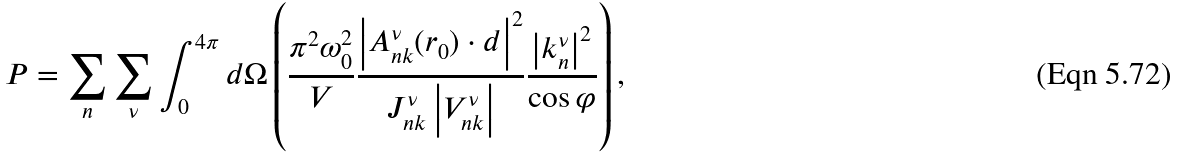<formula> <loc_0><loc_0><loc_500><loc_500>P = \sum _ { n } \sum _ { \nu } \int _ { 0 } ^ { 4 \pi } d \Omega \left ( \frac { \pi ^ { 2 } \omega _ { 0 } ^ { 2 } } { V } \frac { \left | A ^ { \nu } _ { n k } ( r _ { 0 } ) \cdot d \right | ^ { 2 } } { J _ { n k } ^ { \nu } \left | V _ { n k } ^ { \nu } \right | } \frac { \left | k _ { n } ^ { \nu } \right | ^ { 2 } } { \cos \varphi } \right ) ,</formula> 